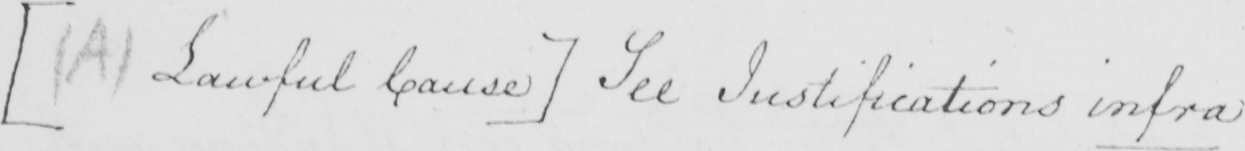What does this handwritten line say? [  ( A )  Lawful Cause ]  See Justifications infra 